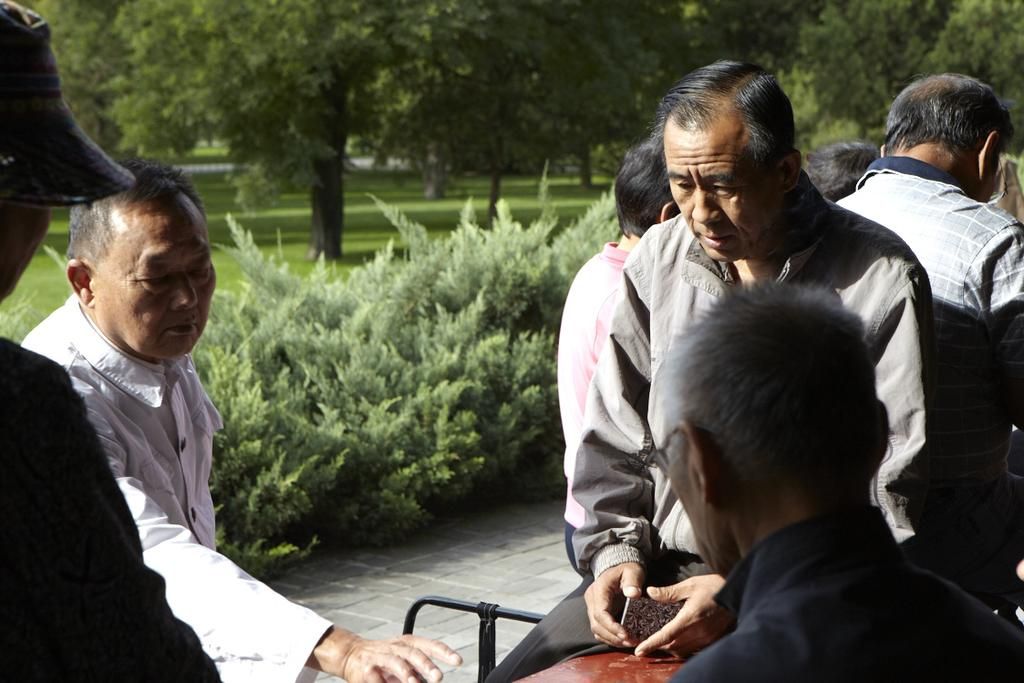Who or what can be seen in the front of the image? There are people in the front of the image. What is located in the middle of the image? There are plants in the middle of the image. What type of vegetation is visible in the background of the image? There are trees and grass visible in the background of the image. What type of wire can be seen connecting the trees in the image? There is no wire connecting the trees in the image; only trees and grass are visible in the background. Can you tell me when the birth of the plants in the middle of the image occurred? The provided facts do not give information about the birth of the plants, so it cannot be determined from the image. 